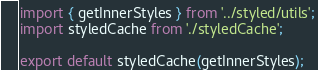Convert code to text. <code><loc_0><loc_0><loc_500><loc_500><_TypeScript_>import { getInnerStyles } from '../styled/utils';
import styledCache from './styledCache';

export default styledCache(getInnerStyles);
</code> 